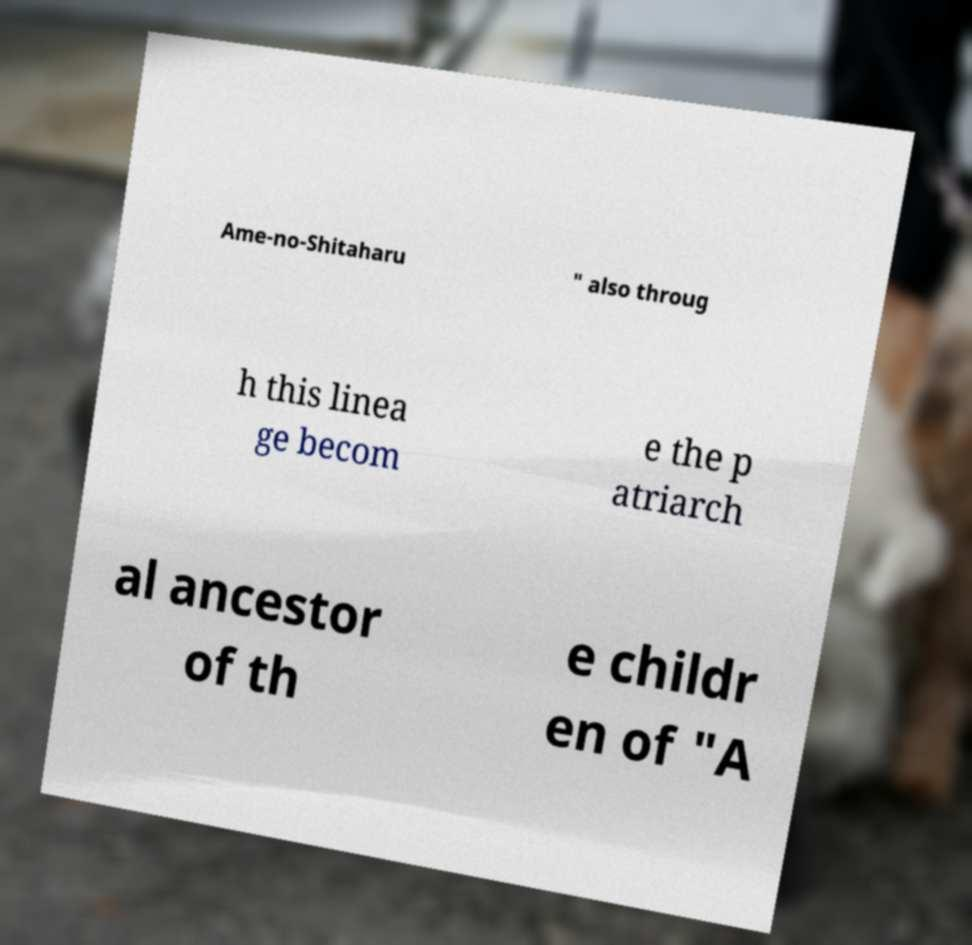Could you assist in decoding the text presented in this image and type it out clearly? Ame-no-Shitaharu " also throug h this linea ge becom e the p atriarch al ancestor of th e childr en of "A 